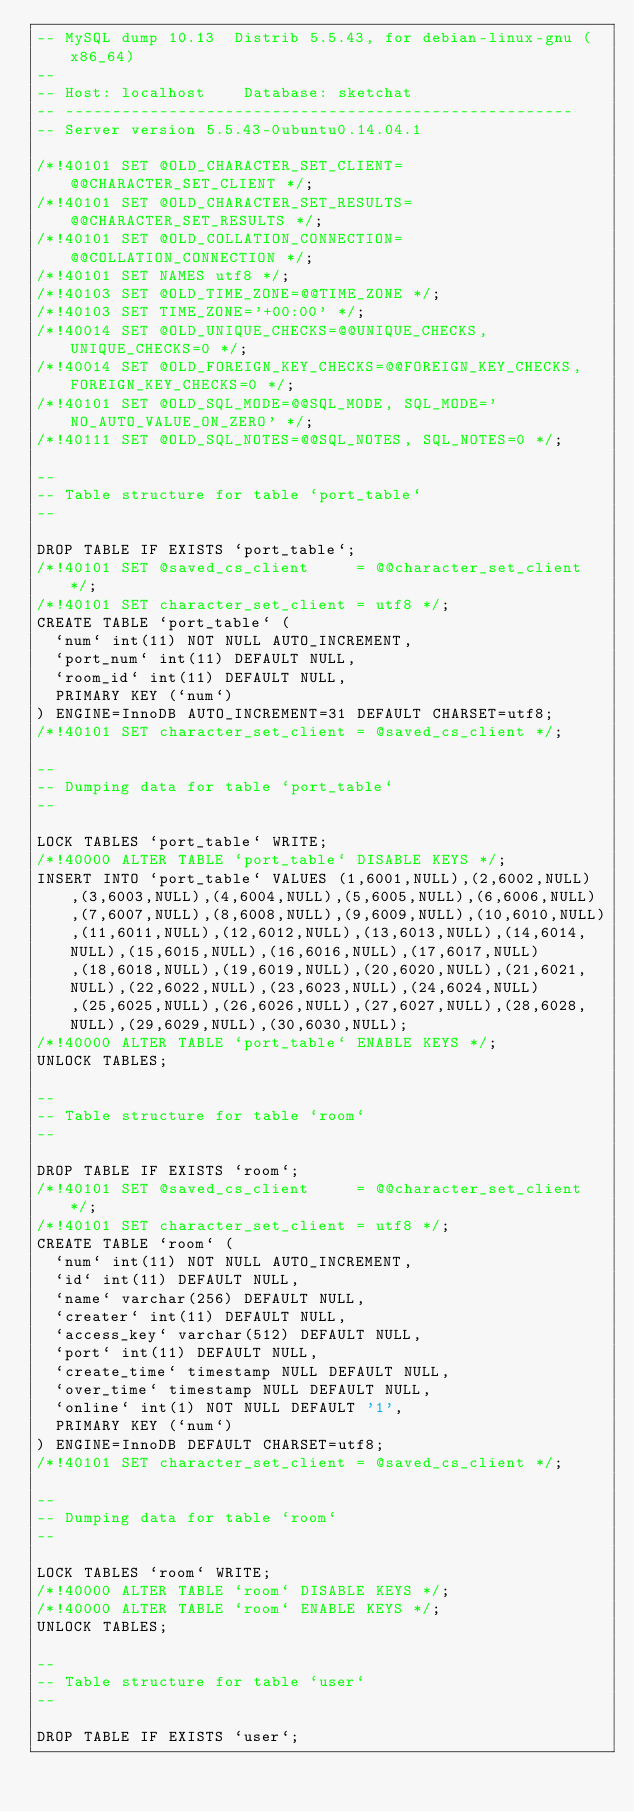<code> <loc_0><loc_0><loc_500><loc_500><_SQL_>-- MySQL dump 10.13  Distrib 5.5.43, for debian-linux-gnu (x86_64)
--
-- Host: localhost    Database: sketchat
-- ------------------------------------------------------
-- Server version	5.5.43-0ubuntu0.14.04.1

/*!40101 SET @OLD_CHARACTER_SET_CLIENT=@@CHARACTER_SET_CLIENT */;
/*!40101 SET @OLD_CHARACTER_SET_RESULTS=@@CHARACTER_SET_RESULTS */;
/*!40101 SET @OLD_COLLATION_CONNECTION=@@COLLATION_CONNECTION */;
/*!40101 SET NAMES utf8 */;
/*!40103 SET @OLD_TIME_ZONE=@@TIME_ZONE */;
/*!40103 SET TIME_ZONE='+00:00' */;
/*!40014 SET @OLD_UNIQUE_CHECKS=@@UNIQUE_CHECKS, UNIQUE_CHECKS=0 */;
/*!40014 SET @OLD_FOREIGN_KEY_CHECKS=@@FOREIGN_KEY_CHECKS, FOREIGN_KEY_CHECKS=0 */;
/*!40101 SET @OLD_SQL_MODE=@@SQL_MODE, SQL_MODE='NO_AUTO_VALUE_ON_ZERO' */;
/*!40111 SET @OLD_SQL_NOTES=@@SQL_NOTES, SQL_NOTES=0 */;

--
-- Table structure for table `port_table`
--

DROP TABLE IF EXISTS `port_table`;
/*!40101 SET @saved_cs_client     = @@character_set_client */;
/*!40101 SET character_set_client = utf8 */;
CREATE TABLE `port_table` (
  `num` int(11) NOT NULL AUTO_INCREMENT,
  `port_num` int(11) DEFAULT NULL,
  `room_id` int(11) DEFAULT NULL,
  PRIMARY KEY (`num`)
) ENGINE=InnoDB AUTO_INCREMENT=31 DEFAULT CHARSET=utf8;
/*!40101 SET character_set_client = @saved_cs_client */;

--
-- Dumping data for table `port_table`
--

LOCK TABLES `port_table` WRITE;
/*!40000 ALTER TABLE `port_table` DISABLE KEYS */;
INSERT INTO `port_table` VALUES (1,6001,NULL),(2,6002,NULL),(3,6003,NULL),(4,6004,NULL),(5,6005,NULL),(6,6006,NULL),(7,6007,NULL),(8,6008,NULL),(9,6009,NULL),(10,6010,NULL),(11,6011,NULL),(12,6012,NULL),(13,6013,NULL),(14,6014,NULL),(15,6015,NULL),(16,6016,NULL),(17,6017,NULL),(18,6018,NULL),(19,6019,NULL),(20,6020,NULL),(21,6021,NULL),(22,6022,NULL),(23,6023,NULL),(24,6024,NULL),(25,6025,NULL),(26,6026,NULL),(27,6027,NULL),(28,6028,NULL),(29,6029,NULL),(30,6030,NULL);
/*!40000 ALTER TABLE `port_table` ENABLE KEYS */;
UNLOCK TABLES;

--
-- Table structure for table `room`
--

DROP TABLE IF EXISTS `room`;
/*!40101 SET @saved_cs_client     = @@character_set_client */;
/*!40101 SET character_set_client = utf8 */;
CREATE TABLE `room` (
  `num` int(11) NOT NULL AUTO_INCREMENT,
  `id` int(11) DEFAULT NULL,
  `name` varchar(256) DEFAULT NULL,
  `creater` int(11) DEFAULT NULL,
  `access_key` varchar(512) DEFAULT NULL,
  `port` int(11) DEFAULT NULL,
  `create_time` timestamp NULL DEFAULT NULL,
  `over_time` timestamp NULL DEFAULT NULL,
  `online` int(1) NOT NULL DEFAULT '1',
  PRIMARY KEY (`num`)
) ENGINE=InnoDB DEFAULT CHARSET=utf8;
/*!40101 SET character_set_client = @saved_cs_client */;

--
-- Dumping data for table `room`
--

LOCK TABLES `room` WRITE;
/*!40000 ALTER TABLE `room` DISABLE KEYS */;
/*!40000 ALTER TABLE `room` ENABLE KEYS */;
UNLOCK TABLES;

--
-- Table structure for table `user`
--

DROP TABLE IF EXISTS `user`;</code> 